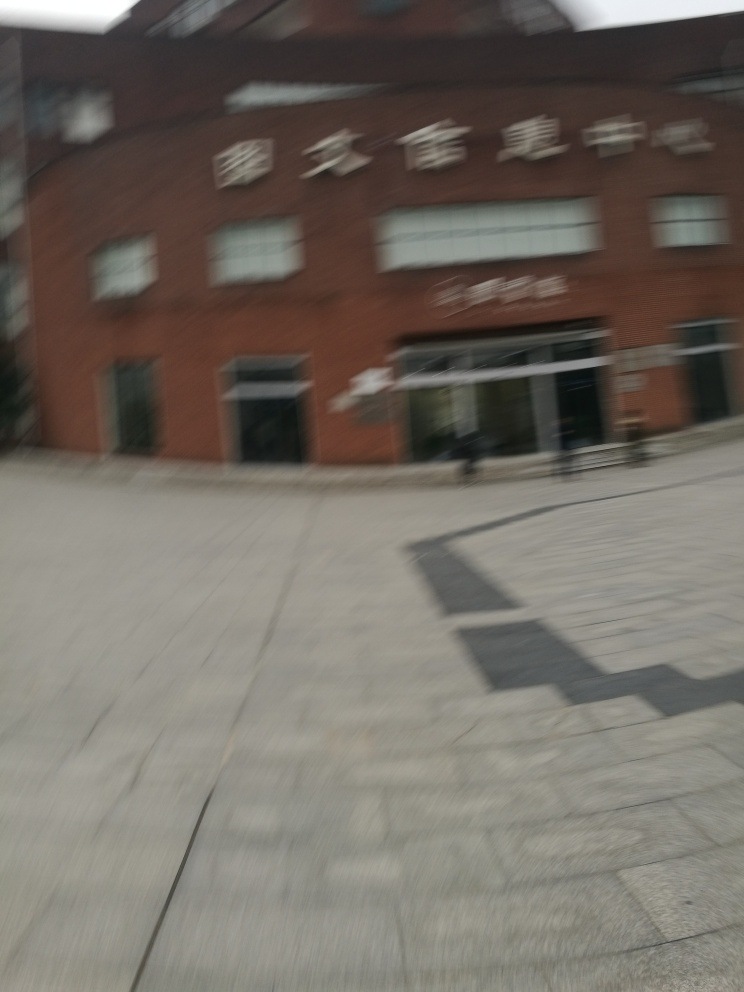What weather conditions or time of day does the image suggest? The lighting in the image doesn't indicate strong sunlight, which could suggest an overcast day or perhaps a time close to dusk or dawn. However, due to the motion blur, these conditions cannot be firmly established. 